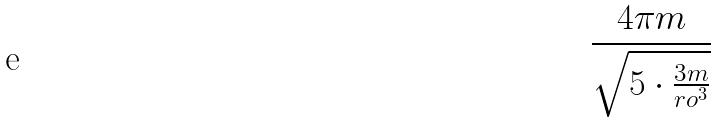<formula> <loc_0><loc_0><loc_500><loc_500>\frac { 4 \pi m } { \sqrt { 5 \cdot \frac { 3 m } { r o ^ { 3 } } } }</formula> 